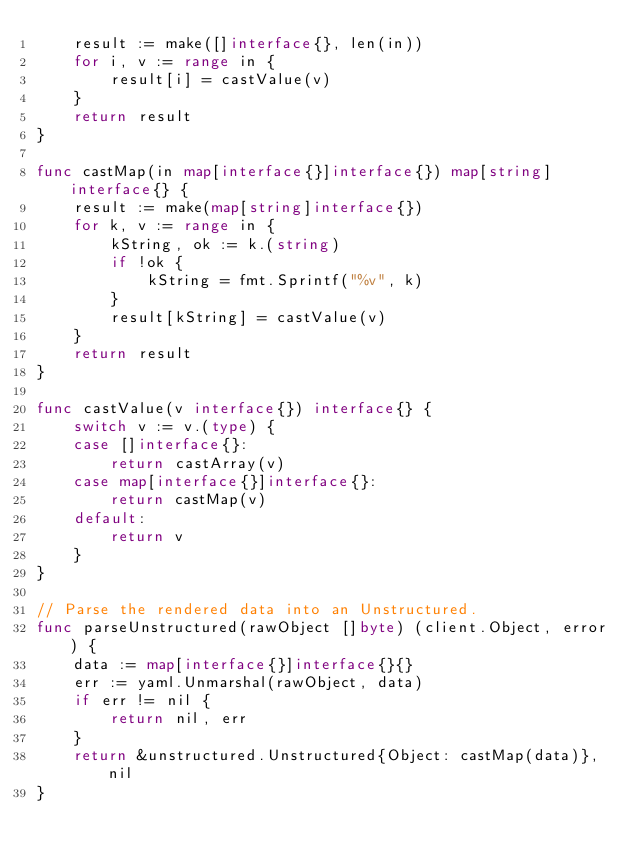<code> <loc_0><loc_0><loc_500><loc_500><_Go_>	result := make([]interface{}, len(in))
	for i, v := range in {
		result[i] = castValue(v)
	}
	return result
}

func castMap(in map[interface{}]interface{}) map[string]interface{} {
	result := make(map[string]interface{})
	for k, v := range in {
		kString, ok := k.(string)
		if !ok {
			kString = fmt.Sprintf("%v", k)
		}
		result[kString] = castValue(v)
	}
	return result
}

func castValue(v interface{}) interface{} {
	switch v := v.(type) {
	case []interface{}:
		return castArray(v)
	case map[interface{}]interface{}:
		return castMap(v)
	default:
		return v
	}
}

// Parse the rendered data into an Unstructured.
func parseUnstructured(rawObject []byte) (client.Object, error) {
	data := map[interface{}]interface{}{}
	err := yaml.Unmarshal(rawObject, data)
	if err != nil {
		return nil, err
	}
	return &unstructured.Unstructured{Object: castMap(data)}, nil
}
</code> 